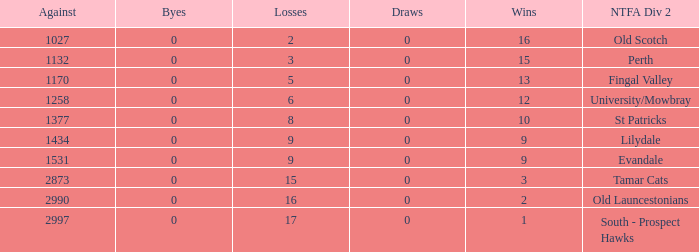What is the lowest number of against of NTFA Div 2 Fingal Valley? 1170.0. 